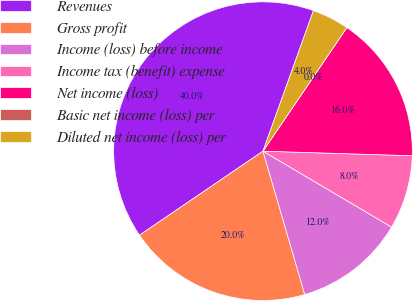<chart> <loc_0><loc_0><loc_500><loc_500><pie_chart><fcel>Revenues<fcel>Gross profit<fcel>Income (loss) before income<fcel>Income tax (benefit) expense<fcel>Net income (loss)<fcel>Basic net income (loss) per<fcel>Diluted net income (loss) per<nl><fcel>40.0%<fcel>20.0%<fcel>12.0%<fcel>8.0%<fcel>16.0%<fcel>0.0%<fcel>4.0%<nl></chart> 